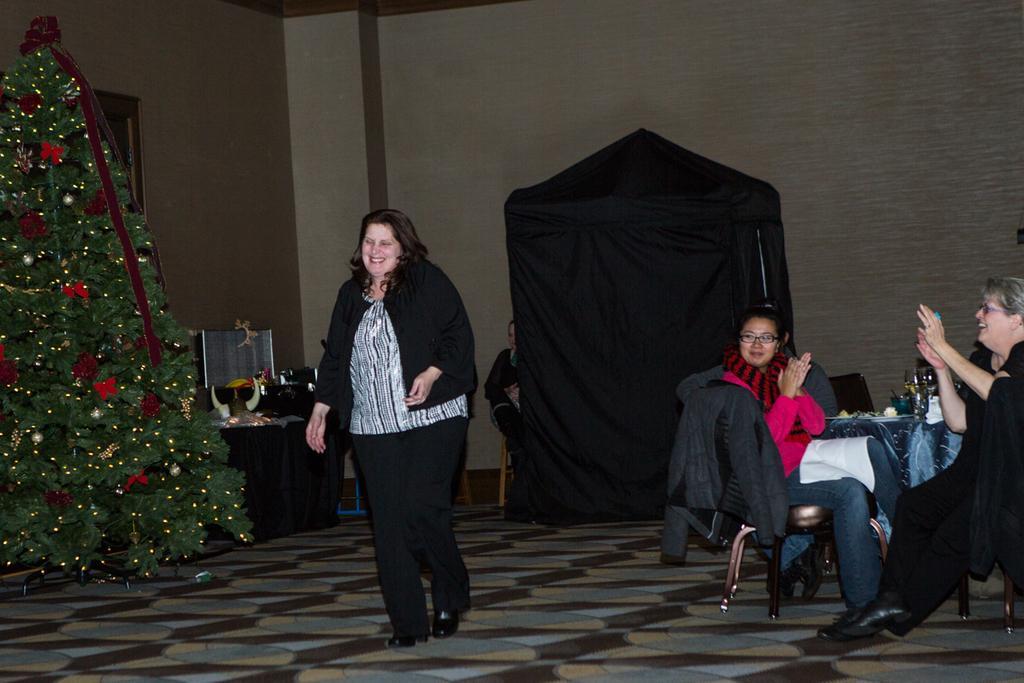Please provide a concise description of this image. In the image we can see there is a woman standing on the floor, there are other people sitting on the chair and on the table there is wine glass kept on the table. Behind there is a decorated christmas tree kept on the floor. 